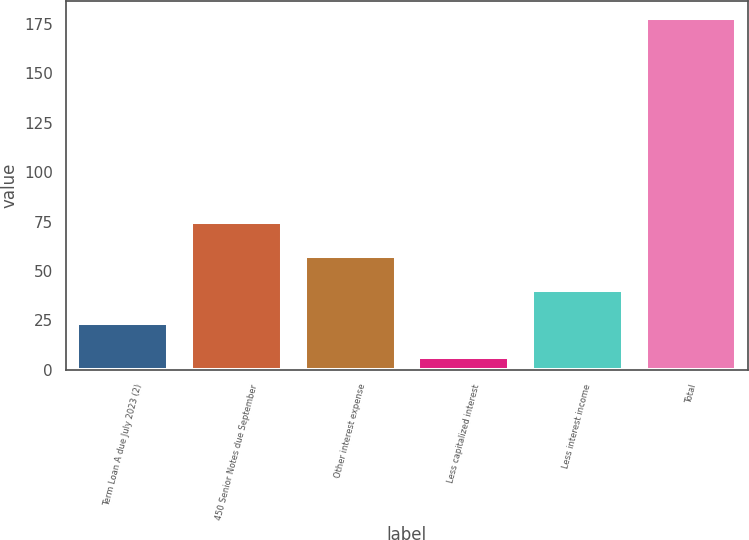Convert chart. <chart><loc_0><loc_0><loc_500><loc_500><bar_chart><fcel>Term Loan A due July 2023 (2)<fcel>450 Senior Notes due September<fcel>Other interest expense<fcel>Less capitalized interest<fcel>Less interest income<fcel>Total<nl><fcel>23.46<fcel>74.94<fcel>57.78<fcel>6.3<fcel>40.62<fcel>177.9<nl></chart> 